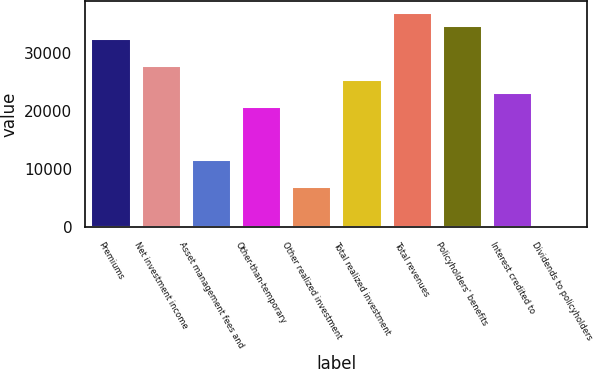<chart> <loc_0><loc_0><loc_500><loc_500><bar_chart><fcel>Premiums<fcel>Net investment income<fcel>Asset management fees and<fcel>Other-than-temporary<fcel>Other realized investment<fcel>Total realized investment<fcel>Total revenues<fcel>Policyholders' benefits<fcel>Interest credited to<fcel>Dividends to policyholders<nl><fcel>32602.6<fcel>27958.8<fcel>11705.5<fcel>20993.1<fcel>7061.7<fcel>25636.9<fcel>37246.4<fcel>34924.5<fcel>23315<fcel>96<nl></chart> 